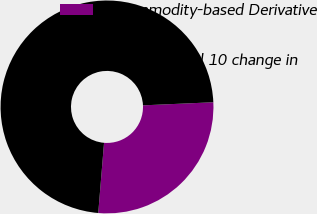Convert chart. <chart><loc_0><loc_0><loc_500><loc_500><pie_chart><fcel>Commodity-based Derivative<fcel>Hypothetical 10 change in<nl><fcel>27.01%<fcel>72.99%<nl></chart> 